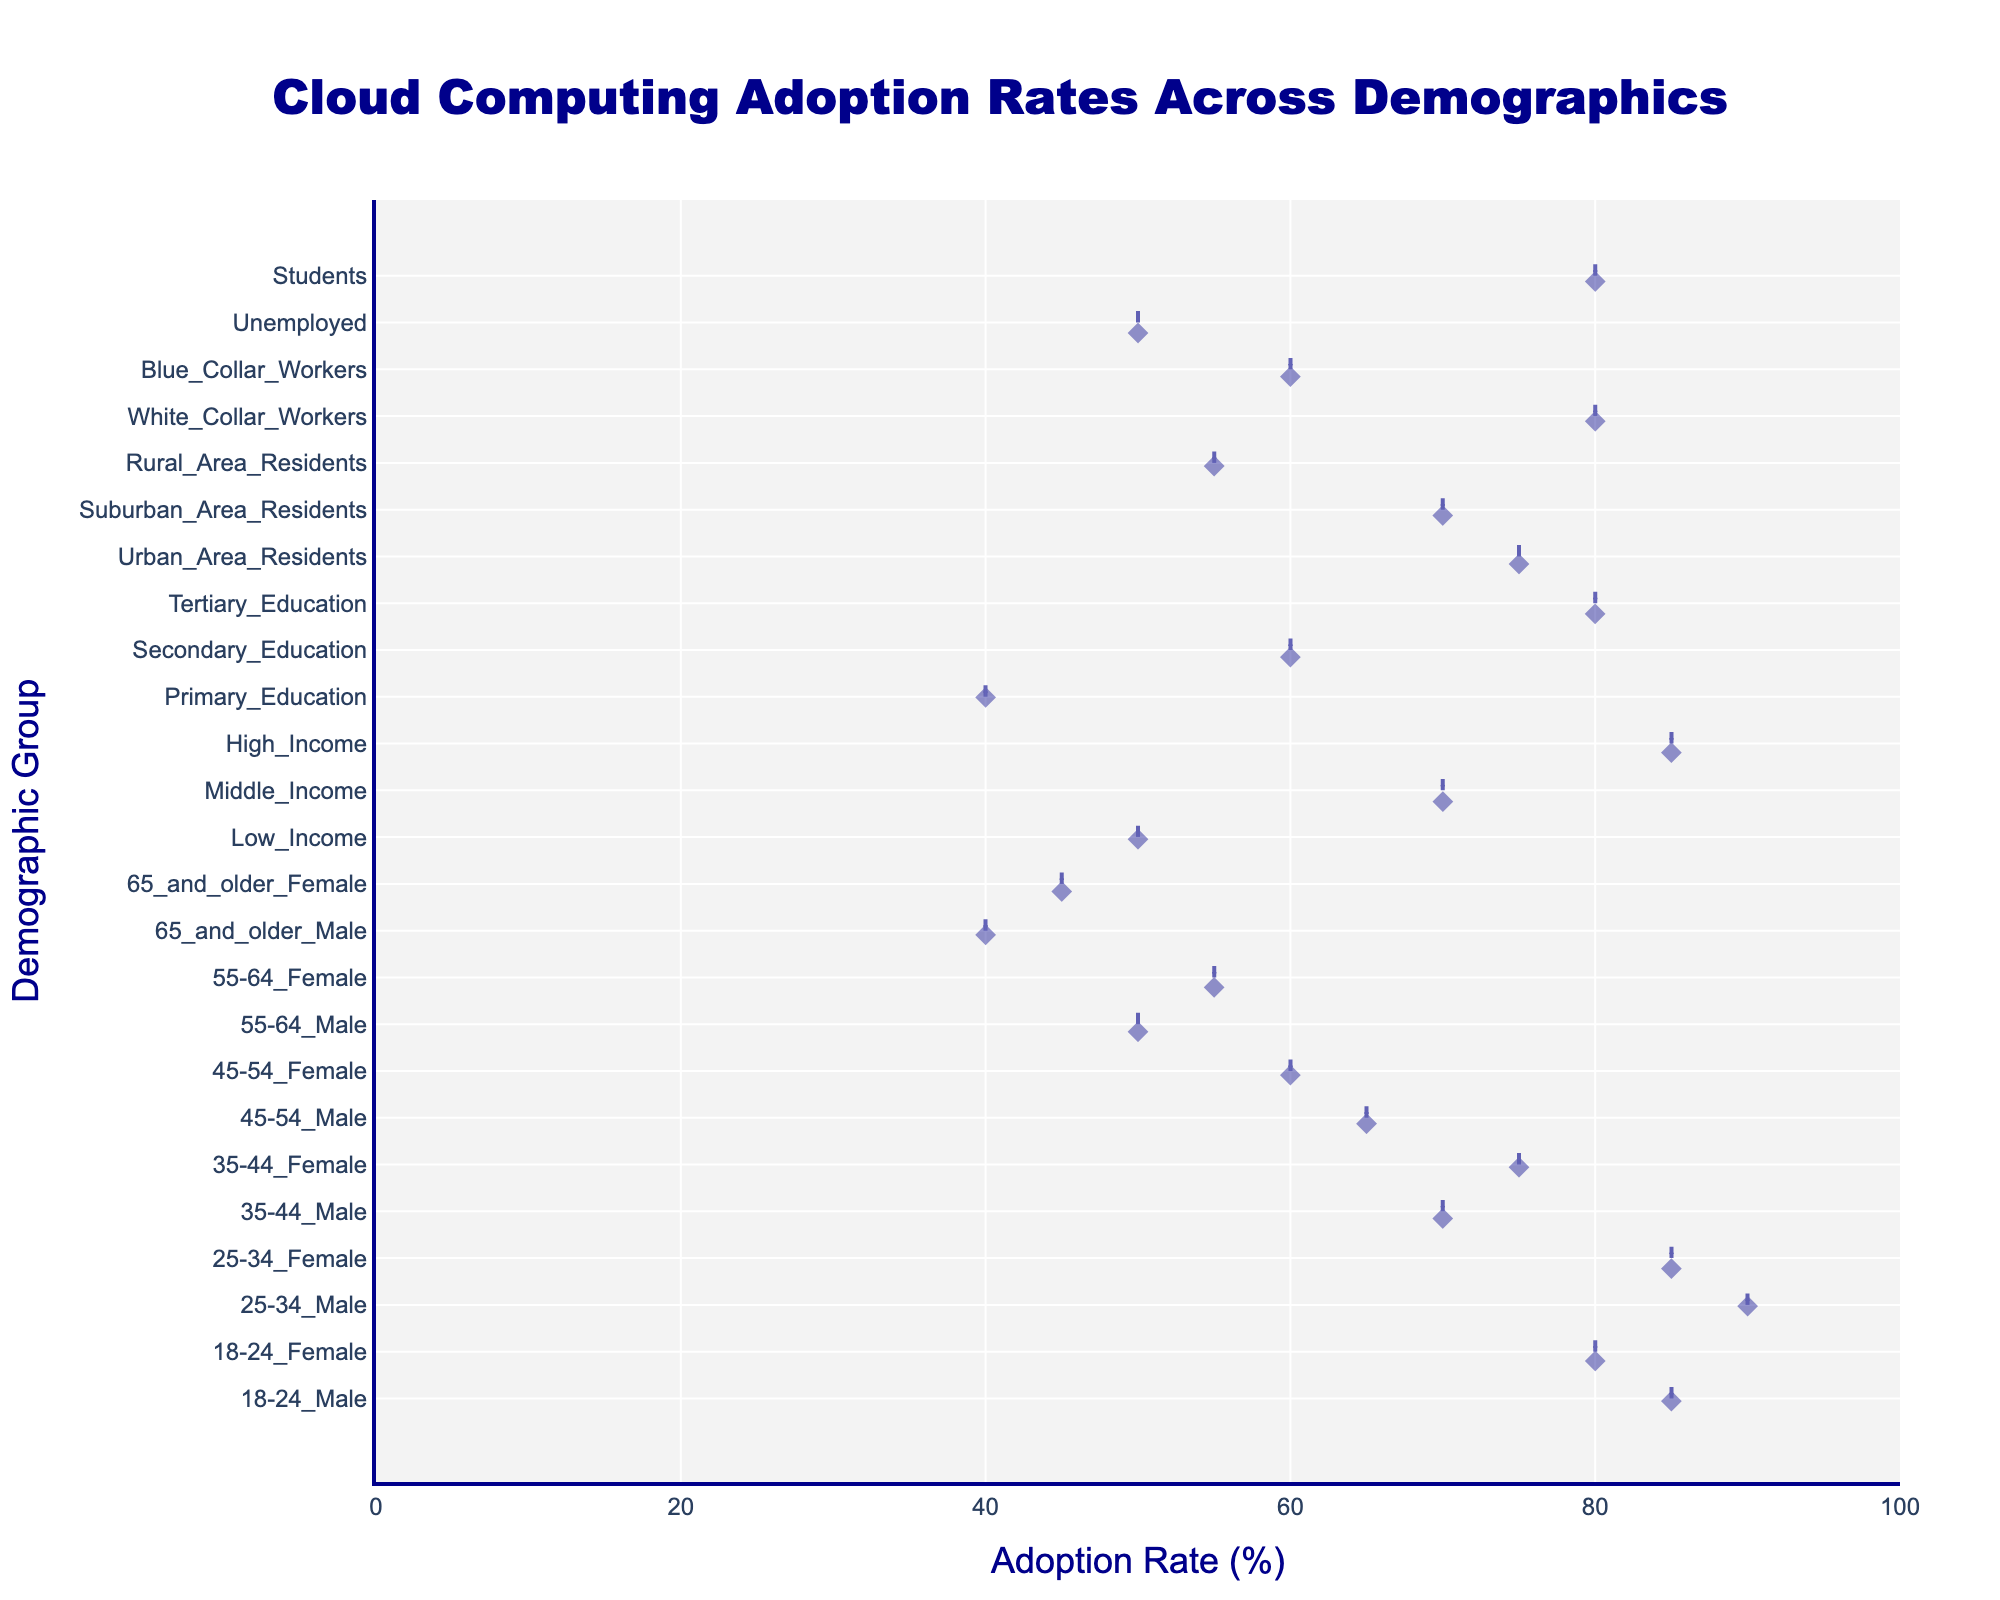What is the title of the plot? The title of the plot is located at the top center of the figure. It reads "Cloud Computing Adoption Rates Across Demographics."
Answer: Cloud Computing Adoption Rates Across Demographics What is the adoption rate percentage for 25-34 Male? Locate the data point on the figure that corresponds to the demographic group "25-34 Male" and read off the adoption rate percentage from the x-axis.
Answer: 90% Which demographic group has the lowest adoption rate? Identify the data point with the smallest x-value on the plot. This corresponds to the group with the lowest adoption rate percentage.
Answer: 65 and older Male How does the adoption rate of 'Students' compare to 'Unemployed'? Find the data points for 'Students' and 'Unemployed' on the plot and compare their x-values. 'Students' has an adoption rate of 80%, while 'Unemployed' has 50%. Therefore, 'Students' have a higher adoption rate.
Answer: Students have a higher adoption rate Which has a higher adoption rate: Low Income or Tertiary Education? Locate the points for 'Low Income' (50%) and 'Tertiary Education' (80%) on the plot and compare the x-values. 'Tertiary Education' has a higher adoption rate than 'Low Income'.
Answer: Tertiary Education What is the difference in adoption rate between 35-44 Female and 45-54 Male? Find the adoption rates for '35-44 Female' and '45-54 Male' on the plot, which are 75% and 65% respectively. Subtract the smaller value from the larger value to get the difference. 75% - 65% = 10%.
Answer: 10% Which demographic group among 'Urban', 'Suburban', and 'Rural Area Residents' shows the highest adoption rate, and what is that rate? Locate the points for these groups on the plot. 'Urban Area Residents' have an adoption rate of 75%, 'Suburban Area Residents' have 70%, and 'Rural Area Residents' have 55%. 'Urban Area Residents' have the highest rate at 75%.
Answer: Urban Area Residents, 75% Is there a significant difference in adoption rates between the different education levels? Compare the points for 'Primary Education' (40%), 'Secondary Education' (60%), and 'Tertiary Education' (80%) on the plot. The differences between each level suggest that there is a significant increase in adoption rate with higher education levels.
Answer: Yes, significant difference What is the adoption rate range observed in the plot? The range is the difference between the highest and lowest adoption rates seen on the plot. The highest adoption rate is 90% (25-34 Male), and the lowest is 40% (Primary Education and 65 and older Male). The range is 90% - 40% = 50%.
Answer: 50% How does the adoption rate for High Income compare to White Collar Workers? Find the points for 'High Income' and 'White Collar Workers' on the plot, which both have an adoption rate of 85%. The x-values are equal, indicating that the adoption rates are the same.
Answer: They are the same 